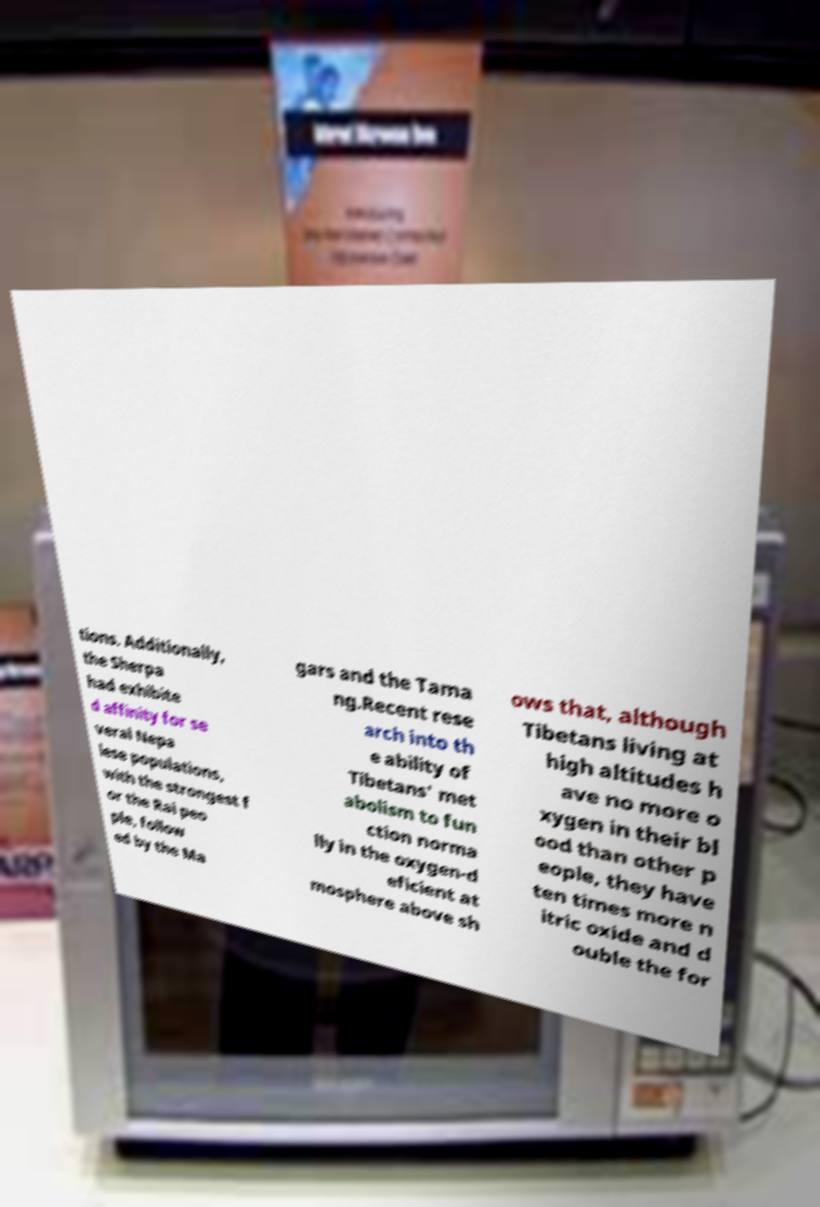For documentation purposes, I need the text within this image transcribed. Could you provide that? tions. Additionally, the Sherpa had exhibite d affinity for se veral Nepa lese populations, with the strongest f or the Rai peo ple, follow ed by the Ma gars and the Tama ng.Recent rese arch into th e ability of Tibetans' met abolism to fun ction norma lly in the oxygen-d eficient at mosphere above sh ows that, although Tibetans living at high altitudes h ave no more o xygen in their bl ood than other p eople, they have ten times more n itric oxide and d ouble the for 